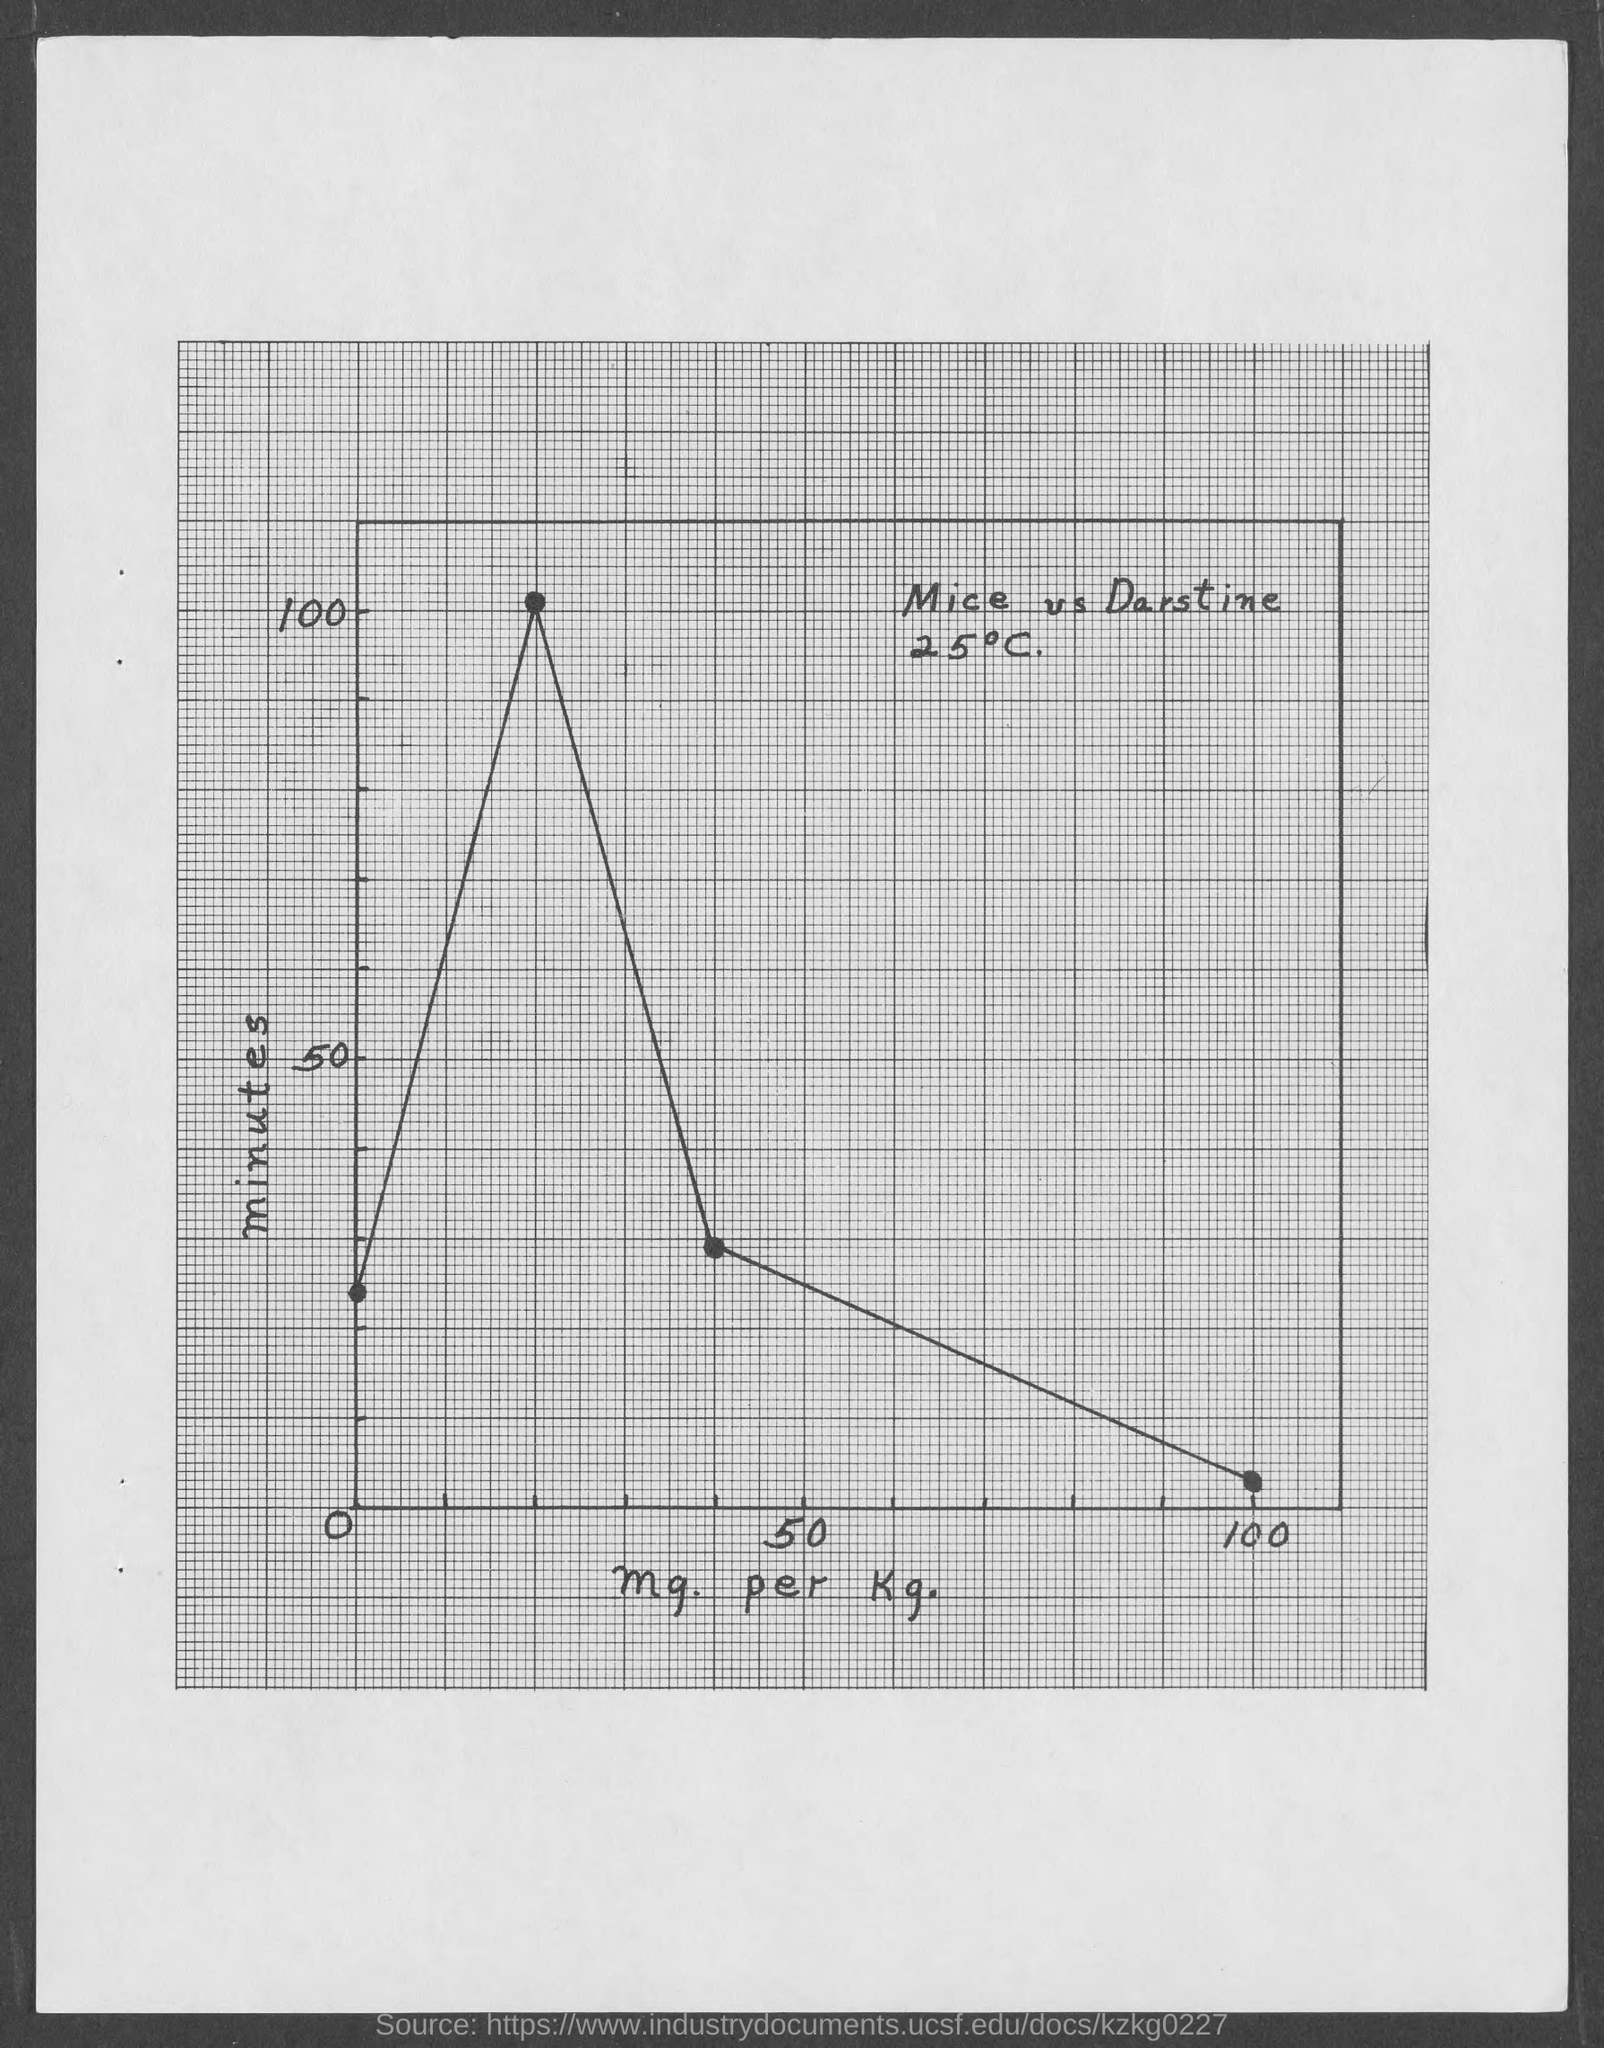Mention a couple of crucial points in this snapshot. The x-axis of the graph represents the mg/kg of the substance being tested. The y-axis of the graph represents the number of minutes, which is the independent variable in this case. 